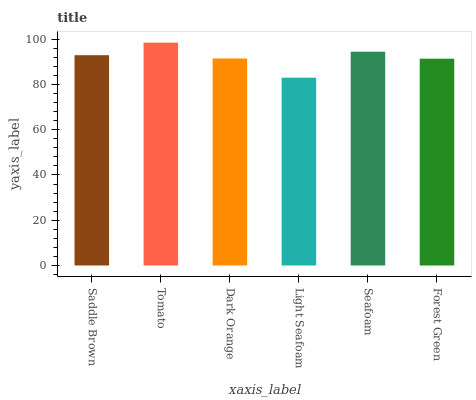Is Light Seafoam the minimum?
Answer yes or no. Yes. Is Tomato the maximum?
Answer yes or no. Yes. Is Dark Orange the minimum?
Answer yes or no. No. Is Dark Orange the maximum?
Answer yes or no. No. Is Tomato greater than Dark Orange?
Answer yes or no. Yes. Is Dark Orange less than Tomato?
Answer yes or no. Yes. Is Dark Orange greater than Tomato?
Answer yes or no. No. Is Tomato less than Dark Orange?
Answer yes or no. No. Is Saddle Brown the high median?
Answer yes or no. Yes. Is Dark Orange the low median?
Answer yes or no. Yes. Is Tomato the high median?
Answer yes or no. No. Is Saddle Brown the low median?
Answer yes or no. No. 